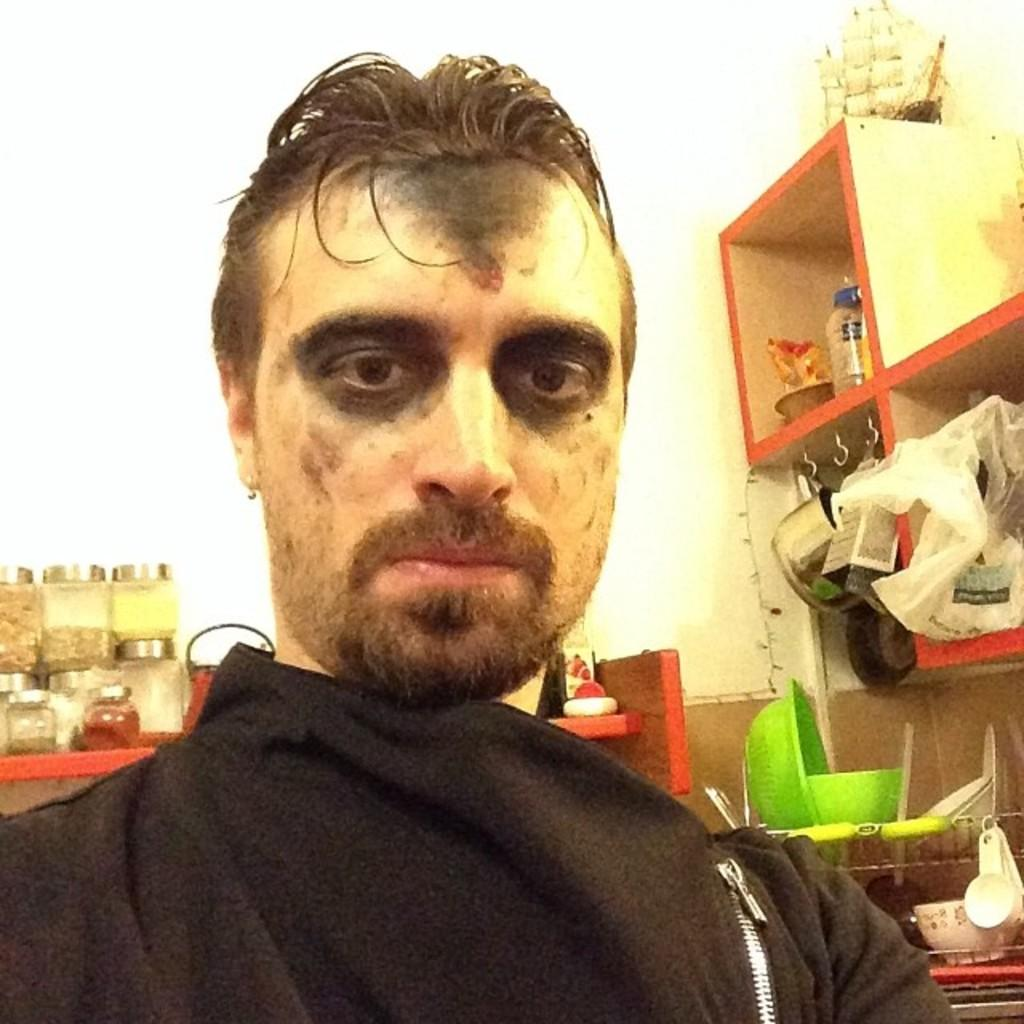Who is present in the image? There is a man in the image. What can be seen on the man's face? There are black color marks on the man's face. What type of containers are visible in the image? There are glass jars visible in the image. What is the shape of the bowl in the image? The bowl's shape cannot be determined from the provided facts. What is the material of the basket in the image? There is a metal basket in the image. What other household items can be seen in the image? Other household items are present in the image, but their specific types cannot be determined from the provided facts. What type of pest is being discussed by the committee in the image? There is no committee or pest present in the image; it features a man with black color marks on his face, glass jars, a bowl, a metal basket, and other household items. 